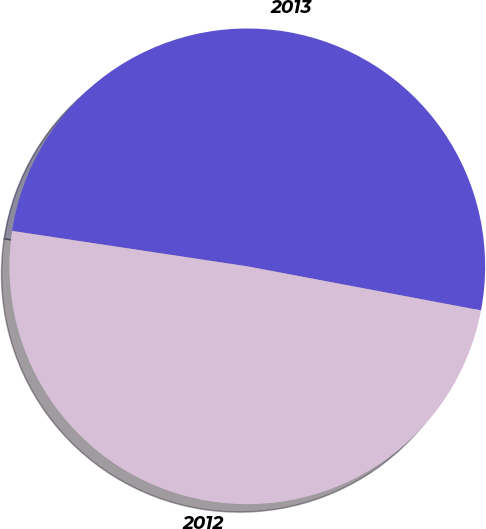<chart> <loc_0><loc_0><loc_500><loc_500><pie_chart><fcel>2013<fcel>2012<nl><fcel>50.59%<fcel>49.41%<nl></chart> 